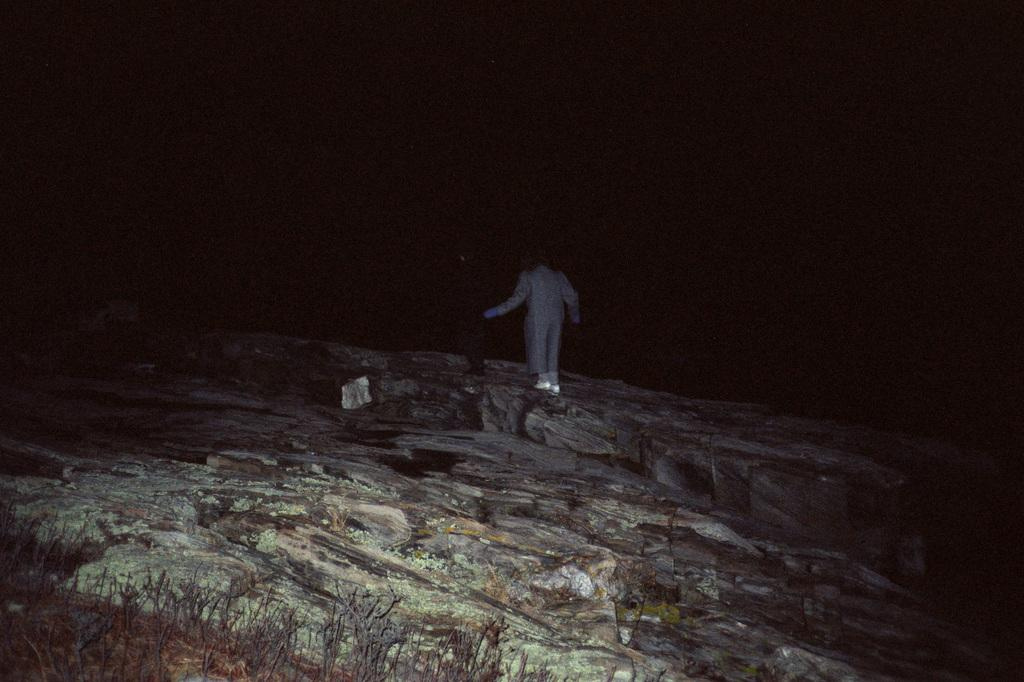What time of day was the image taken? The image was taken during nighttime. What is the person in the image doing? The person is standing on a rock in the middle of the image. How does the top of the image appear? The top of the image appears to be dark. What type of fuel is being used by the hose in the image? There is no hose present in the image, so it is not possible to determine what type of fuel might be used. 